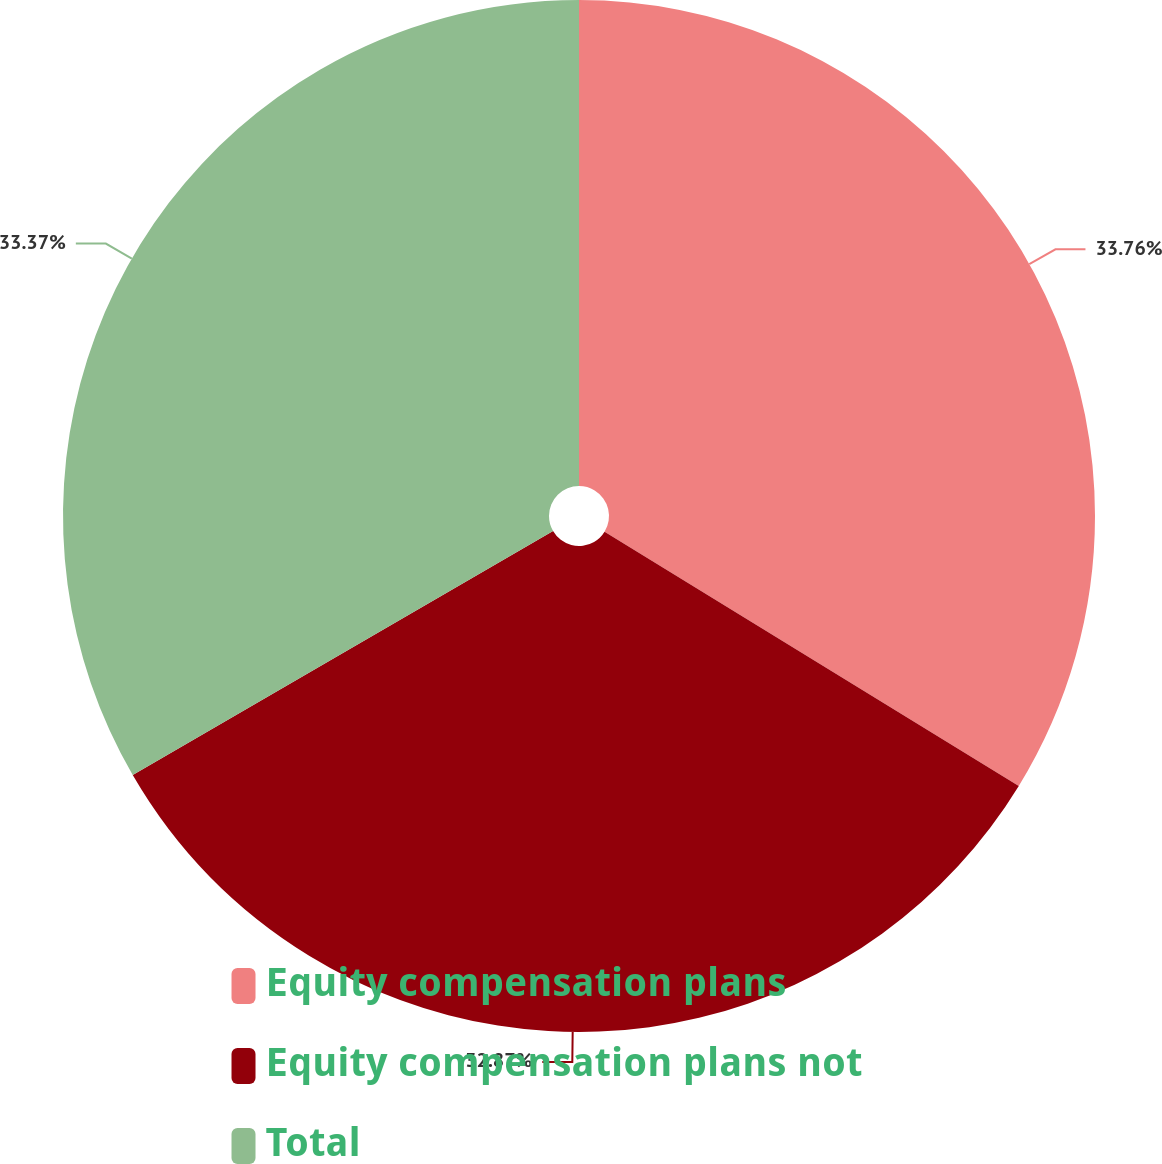Convert chart to OTSL. <chart><loc_0><loc_0><loc_500><loc_500><pie_chart><fcel>Equity compensation plans<fcel>Equity compensation plans not<fcel>Total<nl><fcel>33.76%<fcel>32.87%<fcel>33.37%<nl></chart> 